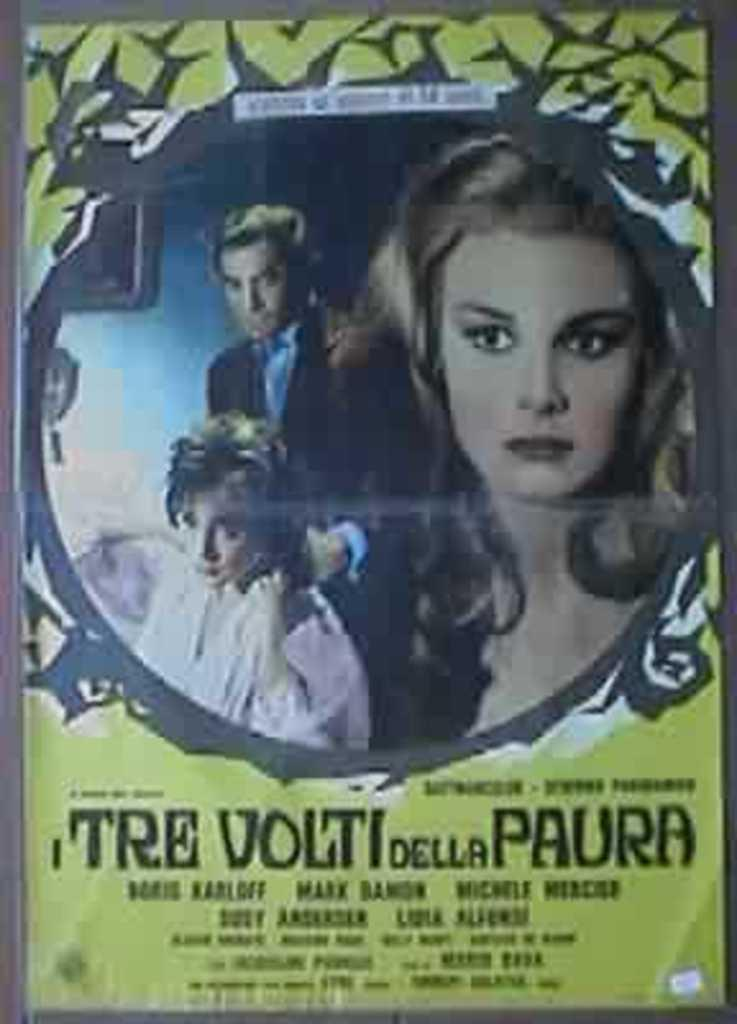What can be found at the bottom of the poster? There is text at the bottom of the poster. What is depicted in the middle of the poster? There are two women and a man in the middle of the poster. What type of seed is being planted by the man in the image? There is no man planting a seed in the image; the image features two women and a man, but no seed or planting activity is depicted. How many rings are visible on the fingers of the women in the image? There is no mention of rings or any jewelry in the image; the focus is on the presence of two women and a man. 